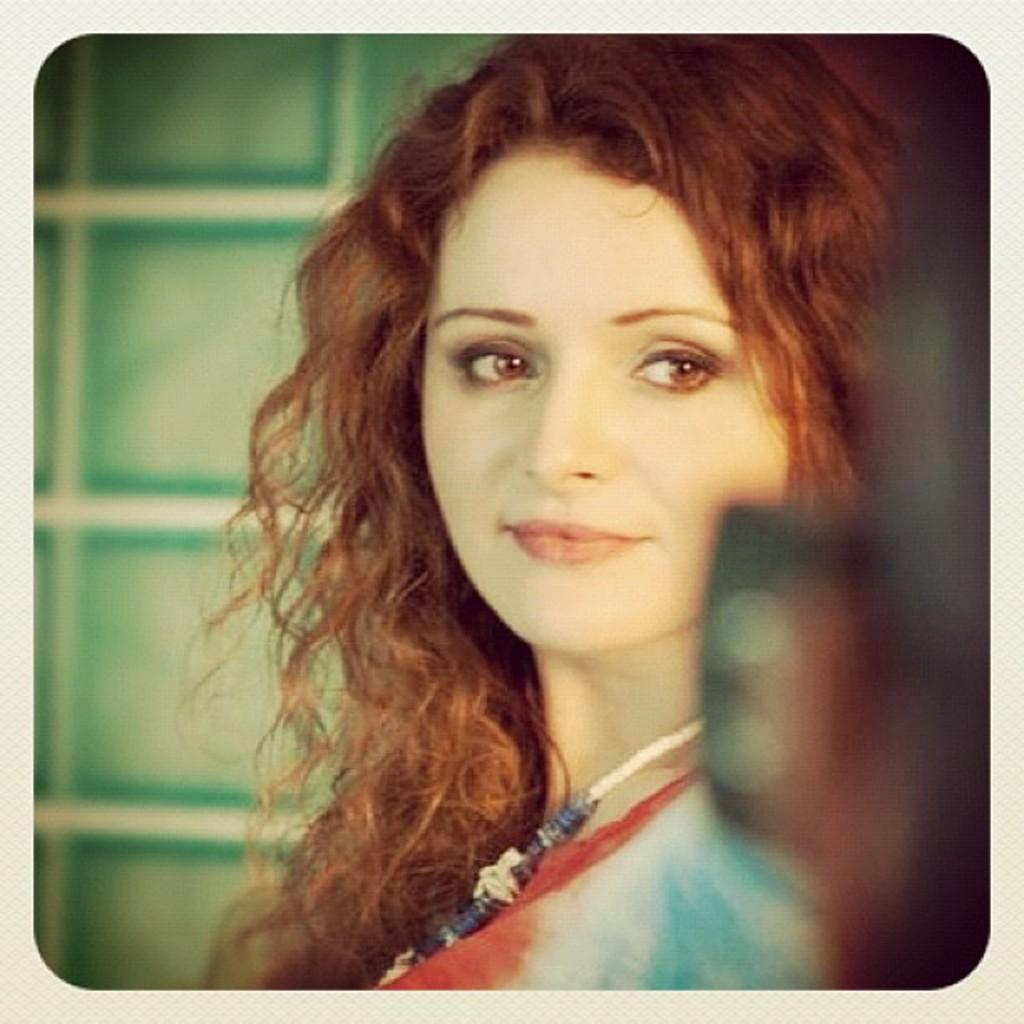What is the main subject of the image? There is a close-up picture of a woman in the image. Can you describe the woman's attire in the image? The woman is wearing clothes in the image. What accessory is the woman wearing in the image? The woman is wearing a neck chain in the image. What is the woman's facial expression in the image? The woman is smiling in the image. How is the image framed or presented? The corners of the image are blurred. What type of bait is the woman using in the image? There is no bait present in the image; it features a close-up picture of a woman. What color is the ink on the woman's shirt in the image? There is no ink visible on the woman's shirt in the image; it only shows her wearing clothes and a neck chain. 